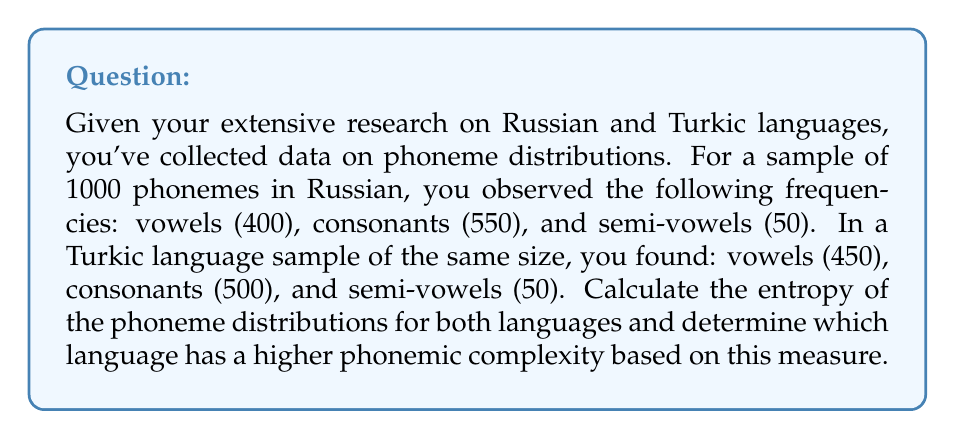Provide a solution to this math problem. To solve this problem, we'll use the concept of entropy from information theory, which measures the average amount of information contained in a random variable. In this case, our random variable is the occurrence of a phoneme type (vowel, consonant, or semi-vowel) in each language.

The formula for entropy is:

$$H = -\sum_{i=1}^{n} p_i \log_2(p_i)$$

Where $p_i$ is the probability of each outcome, and $n$ is the number of possible outcomes.

Step 1: Calculate probabilities for Russian
$p(\text{vowel}) = 400/1000 = 0.4$
$p(\text{consonant}) = 550/1000 = 0.55$
$p(\text{semi-vowel}) = 50/1000 = 0.05$

Step 2: Calculate entropy for Russian
$$H_R = -[0.4 \log_2(0.4) + 0.55 \log_2(0.55) + 0.05 \log_2(0.05)]$$
$$H_R = -(0.4 \cdot (-1.32) + 0.55 \cdot (-0.862) + 0.05 \cdot (-4.32))$$
$$H_R = 0.528 + 0.474 + 0.216 = 1.218$$

Step 3: Calculate probabilities for Turkic language
$p(\text{vowel}) = 450/1000 = 0.45$
$p(\text{consonant}) = 500/1000 = 0.5$
$p(\text{semi-vowel}) = 50/1000 = 0.05$

Step 4: Calculate entropy for Turkic language
$$H_T = -[0.45 \log_2(0.45) + 0.5 \log_2(0.5) + 0.05 \log_2(0.05)]$$
$$H_T = -(0.45 \cdot (-1.15) + 0.5 \cdot (-1) + 0.05 \cdot (-4.32))$$
$$H_T = 0.518 + 0.5 + 0.216 = 1.234$$

Step 5: Compare entropies
The Turkic language has a slightly higher entropy (1.234) compared to Russian (1.218), indicating a marginally higher phonemic complexity based on this measure.
Answer: Russian entropy: 1.218
Turkic language entropy: 1.234
The Turkic language has a higher phonemic complexity based on entropy. 